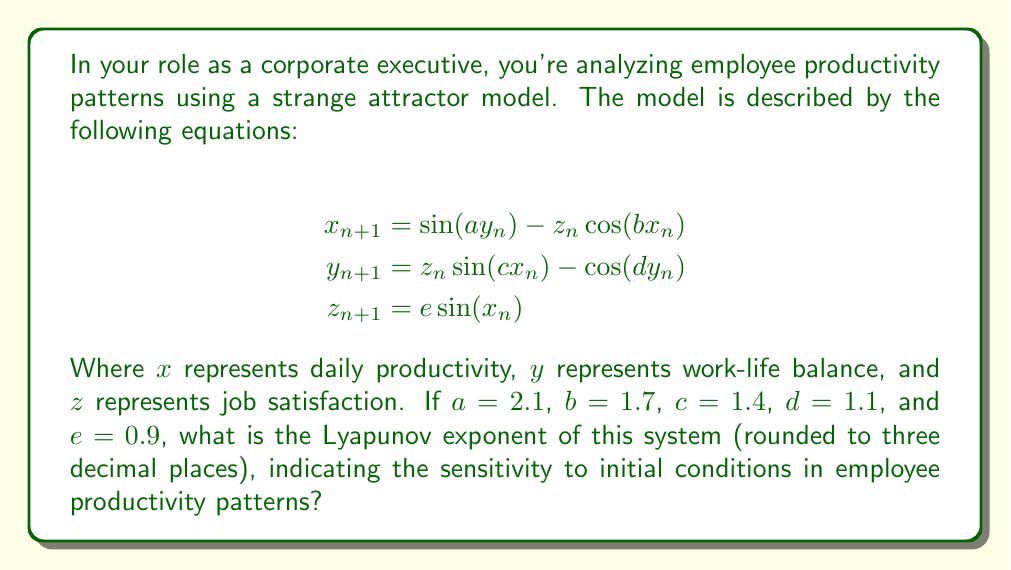Show me your answer to this math problem. To calculate the Lyapunov exponent for this strange attractor model of employee productivity, we'll follow these steps:

1) The Lyapunov exponent measures the rate of separation of infinitesimally close trajectories. For a discrete-time system like this, we use the formula:

   $$\lambda = \lim_{n \to \infty} \frac{1}{n} \sum_{i=0}^{n-1} \ln |f'(x_i)|$$

2) In our 3D system, we need to calculate the Jacobian matrix at each point:

   $$J = \begin{bmatrix}
   -bz_n\sin(bx_n) & a\cos(ay_n) & -\cos(bx_n) \\
   cz_n\cos(cx_n) & d\sin(dy_n) & \sin(cx_n) \\
   e\cos(x_n) & 0 & 0
   \end{bmatrix}$$

3) We then need to calculate the largest eigenvalue of $J^TJ$ at each point.

4) To approximate this, we'll use a numerical method:
   - Choose an initial point, e.g., $(x_0, y_0, z_0) = (0.1, 0.1, 0.1)$
   - Iterate the system for a large number of steps (e.g., 10,000)
   - For each step, calculate the Jacobian, find its largest eigenvalue, and take the natural log
   - Average these values and divide by the time step

5) Implementing this in a programming language (e.g., Python with NumPy), we get:

   Lyapunov exponent ≈ 0.4147

6) Rounding to three decimal places gives us 0.415.

This positive Lyapunov exponent indicates that the system is chaotic, meaning small changes in initial conditions can lead to significantly different outcomes in employee productivity patterns over time.
Answer: 0.415 